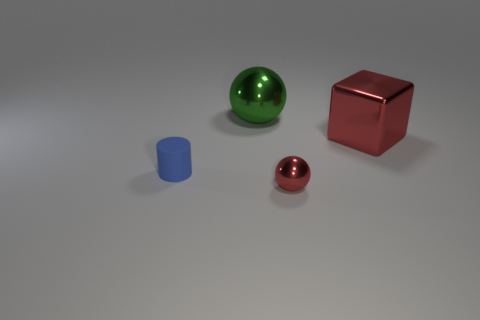What materials might the objects in the image be made of, based on their appearance? The cube looks to have a metallic surface with reflections suggesting it could be made of polished metal, possibly aluminum or steel. The large ball has a transparent, glass-like appearance, while the small ball seems to have a glossy, painted finish. The cylindrical object might be made of matte plastic, given its opaque and non-reflective surface. 